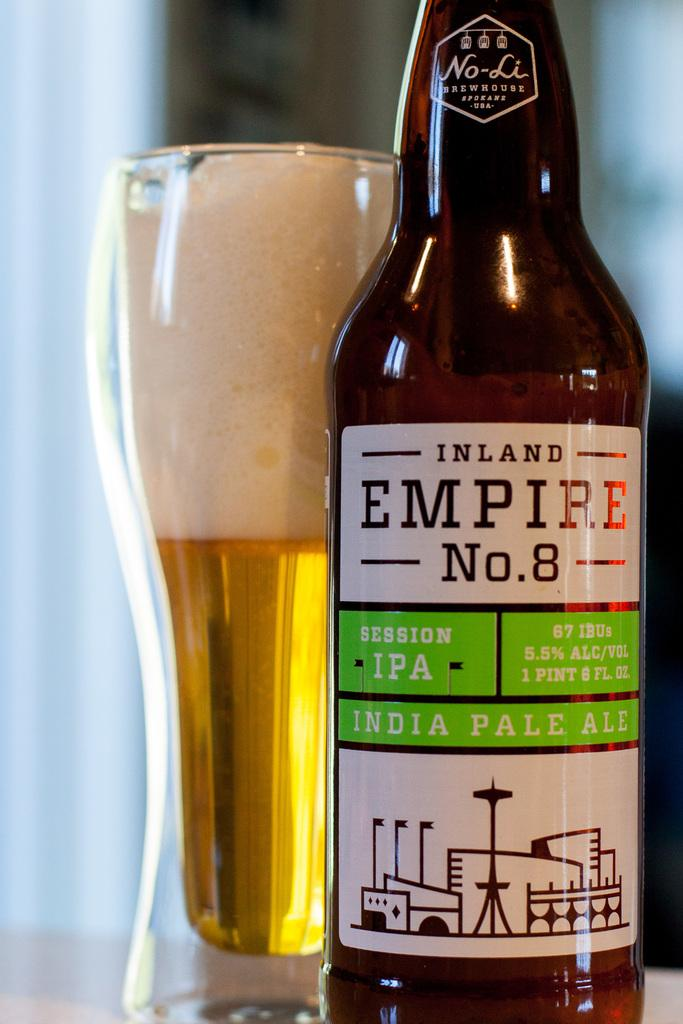Provide a one-sentence caption for the provided image. A bottle of Inland Empire No. 8 India Pale Ale beer is poured in a glass. 